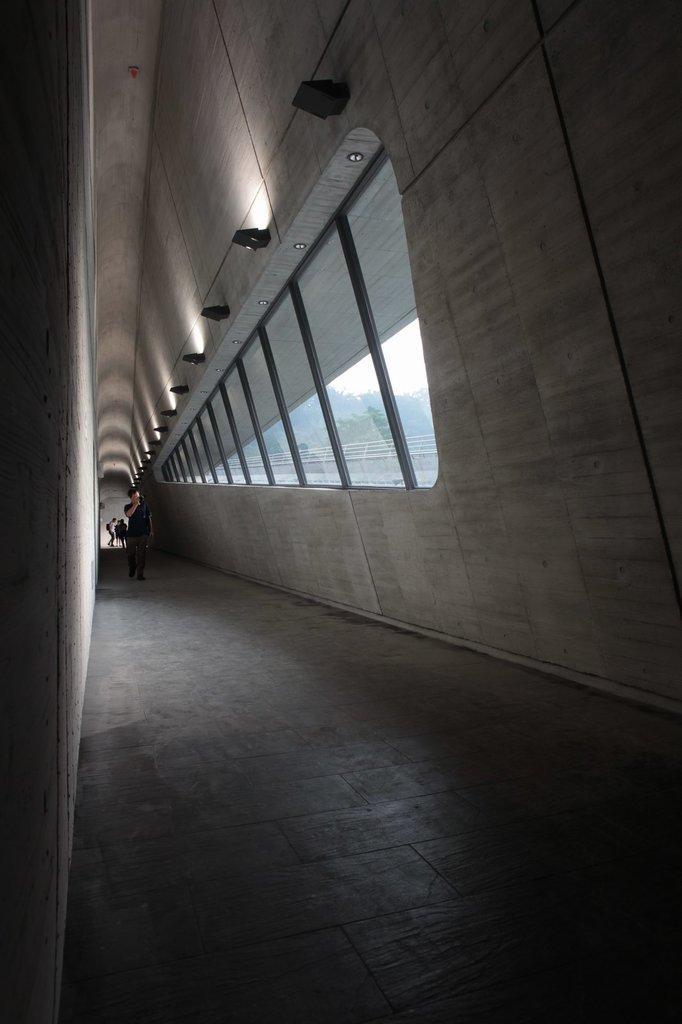Describe this image in one or two sentences. In this picture we can see a person on the floor, walls, glass, lights and at the back of this person we can see some people and in the background we can see trees, some objects and the sky. 